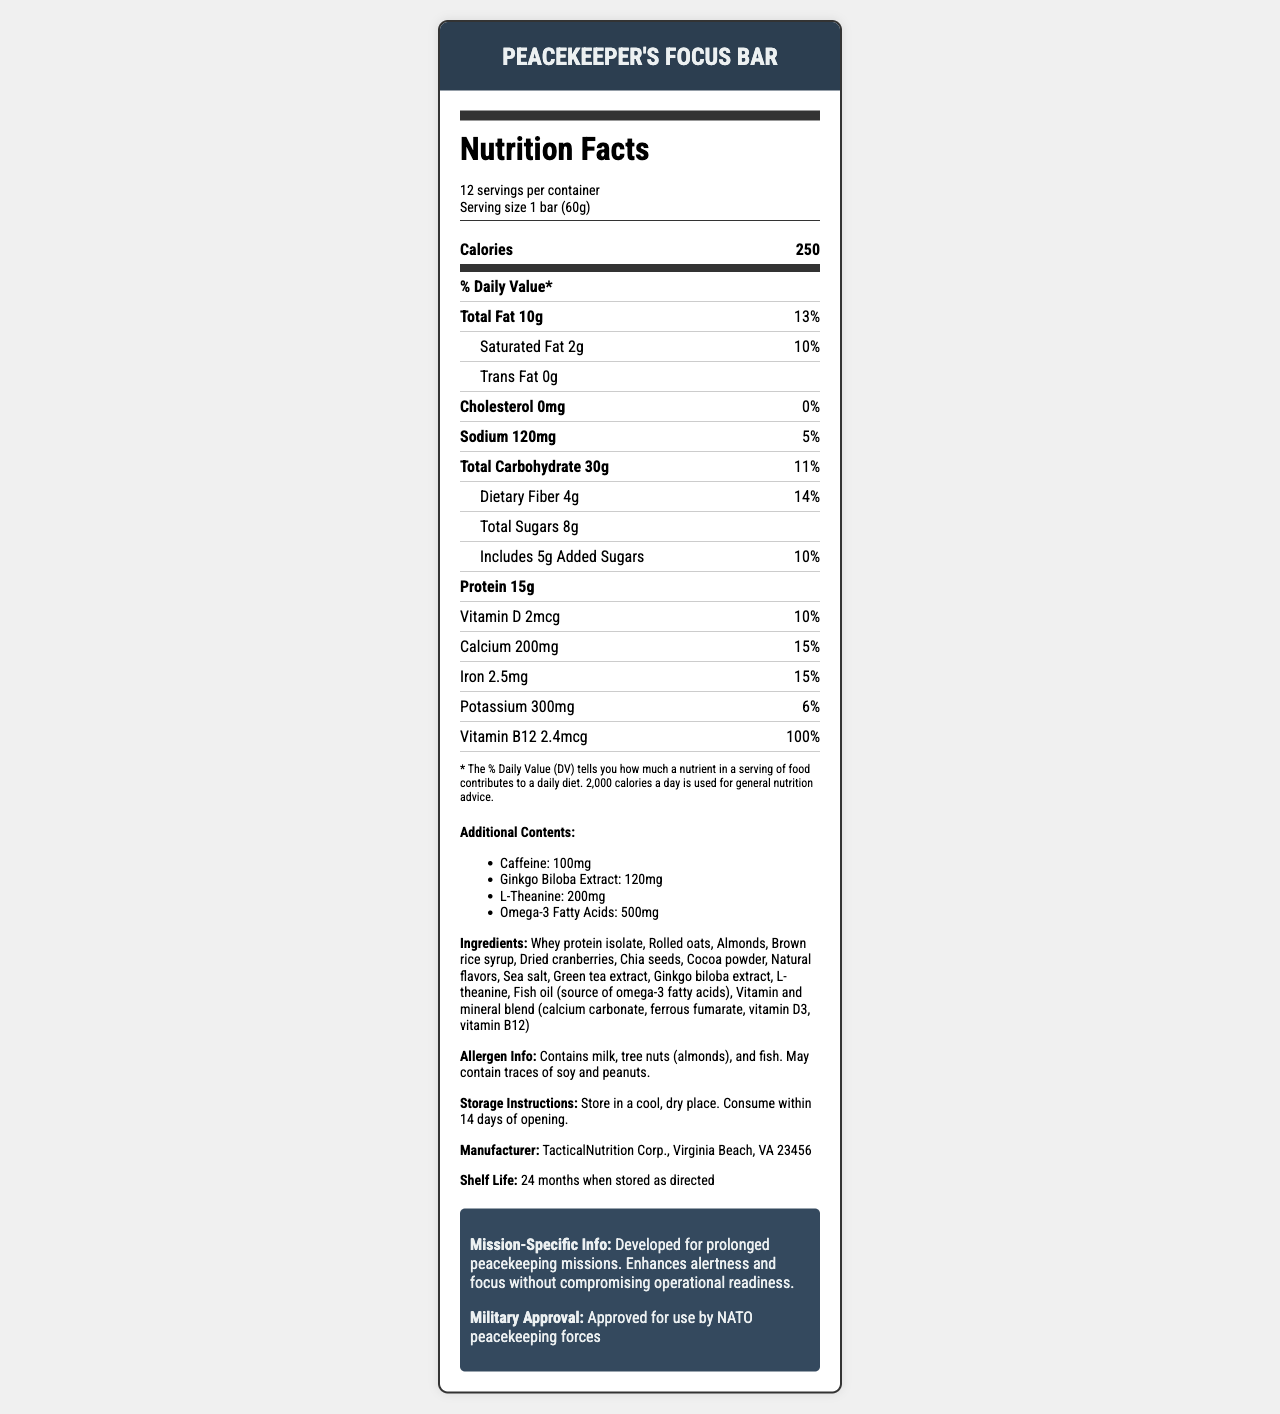what is the serving size? The document specifies that the serving size is 1 bar, which weighs 60 grams.
Answer: 1 bar (60g) how many servings are in each container? The document states that there are 12 servings per container.
Answer: 12 how much protein does each bar contain? The document indicates that each bar contains 15 grams of protein.
Answer: 15g what is the total carbohydrate content per serving? The document lists the total carbohydrate content as 30 grams per serving.
Answer: 30g how much caffeine is in each bar? The document mentions that each bar contains 100 milligrams of caffeine.
Answer: 100mg what percentage of the daily value of saturated fat does one bar provide? A. 5% B. 10% C. 13% D. 15% The document states that one bar provides 2 grams of saturated fat, which is 10% of the daily value.
Answer: B. 10% how much dietary fiber is in each serving? A. 2g B. 4g C. 6g D. 8g The document shows that each serving contains 4 grams of dietary fiber.
Answer: B. 4g is the PeaceKeeper's Focus Bar suitable for people with peanut allergies? The document states that the bar contains almonds and may contain traces of soy and peanuts, so it may not be suitable for people with peanut allergies.
Answer: It may not be suitable is the product developed for short-term missions? The document specifies that the product is developed for prolonged peacekeeping missions.
Answer: No which nutrient is provided at 100% of its daily value? The document states that each bar provides 2.4 micrograms of Vitamin B12, which is 100% of the daily value.
Answer: Vitamin B12 how many calories does each bar contain? The document specifies that each bar contains 250 calories.
Answer: 250 what is the main idea of the document? The document details the nutritional facts, ingredients, allergens, manufacturer, and mission-specific information about the energy bar.
Answer: The document provides the nutritional information for the PeaceKeeper's Focus Bar, designed to enhance alertness and focus during prolonged peacekeeping missions. how should the PeaceKeeper's Focus Bar be stored? The document advises storing the bar in a cool, dry place and consuming it within 14 days of opening.
Answer: In a cool, dry place how much omega-3 fatty acids does each bar have? The document lists that each bar contains 500 milligrams of omega-3 fatty acids.
Answer: 500mg who is the manufacturer of the PeaceKeeper's Focus Bar? The document states that the bar is manufactured by TacticalNutrition Corp., located in Virginia Beach, VA.
Answer: TacticalNutrition Corp., Virginia Beach, VA 23456 what is not included in the ingredients list? A. Whey protein isolate B. Cocoa powder C. Glucose syrup D. Brown rice syrup The ingredients list in the document includes whey protein isolate, cocoa powder, and brown rice syrup but does not mention glucose syrup.
Answer: C. Glucose syrup which vitamins and minerals are present in the vitamin and mineral blend? The document lists the vitamin and mineral blend ingredients as calcium carbonate, ferrous fumarate, vitamin D3, and vitamin B12.
Answer: Calcium, iron, vitamin D3, vitamin B12 was this product approved for use by NATO peacekeeping forces? The document states that the product is approved for use by NATO peacekeeping forces.
Answer: Yes how much does one serving of PeaceKeeper's Focus Bar contribute to the daily value of protein? The document specifies the protein amount but does not provide the daily value percentage for protein.
Answer: Not enough information 